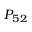<formula> <loc_0><loc_0><loc_500><loc_500>P _ { 5 2 }</formula> 